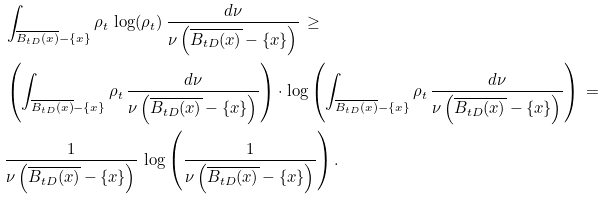Convert formula to latex. <formula><loc_0><loc_0><loc_500><loc_500>& \int _ { \overline { B _ { t D } ( x ) } - \{ x \} } \rho _ { t } \, \log ( \rho _ { t } ) \, \frac { d \nu } { \nu \left ( \overline { B _ { t D } ( x ) } - \{ x \} \right ) } \, \geq \\ & \left ( \int _ { \overline { B _ { t D } ( x ) } - \{ x \} } \rho _ { t } \, \frac { d \nu } { \nu \left ( \overline { B _ { t D } ( x ) } - \{ x \} \right ) } \right ) \cdot \log \left ( \int _ { \overline { B _ { t D } ( x ) } - \{ x \} } \rho _ { t } \, \frac { d \nu } { \nu \left ( \overline { B _ { t D } ( x ) } - \{ x \} \right ) } \right ) \, = \\ & \frac { 1 } { \nu \left ( \overline { B _ { t D } ( x ) } - \{ x \} \right ) } \, \log \left ( \frac { 1 } { \nu \left ( \overline { B _ { t D } ( x ) } - \{ x \} \right ) } \right ) .</formula> 